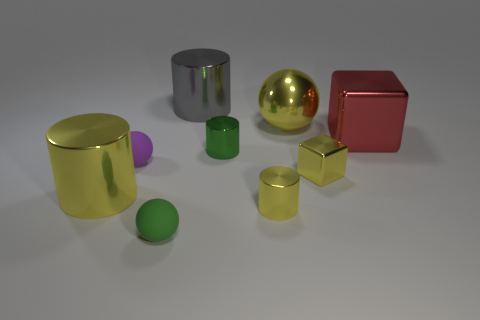Add 1 large brown balls. How many objects exist? 10 Subtract all balls. How many objects are left? 6 Add 6 small metallic cylinders. How many small metallic cylinders exist? 8 Subtract 0 gray cubes. How many objects are left? 9 Subtract all large shiny objects. Subtract all big green cubes. How many objects are left? 5 Add 4 large gray shiny things. How many large gray shiny things are left? 5 